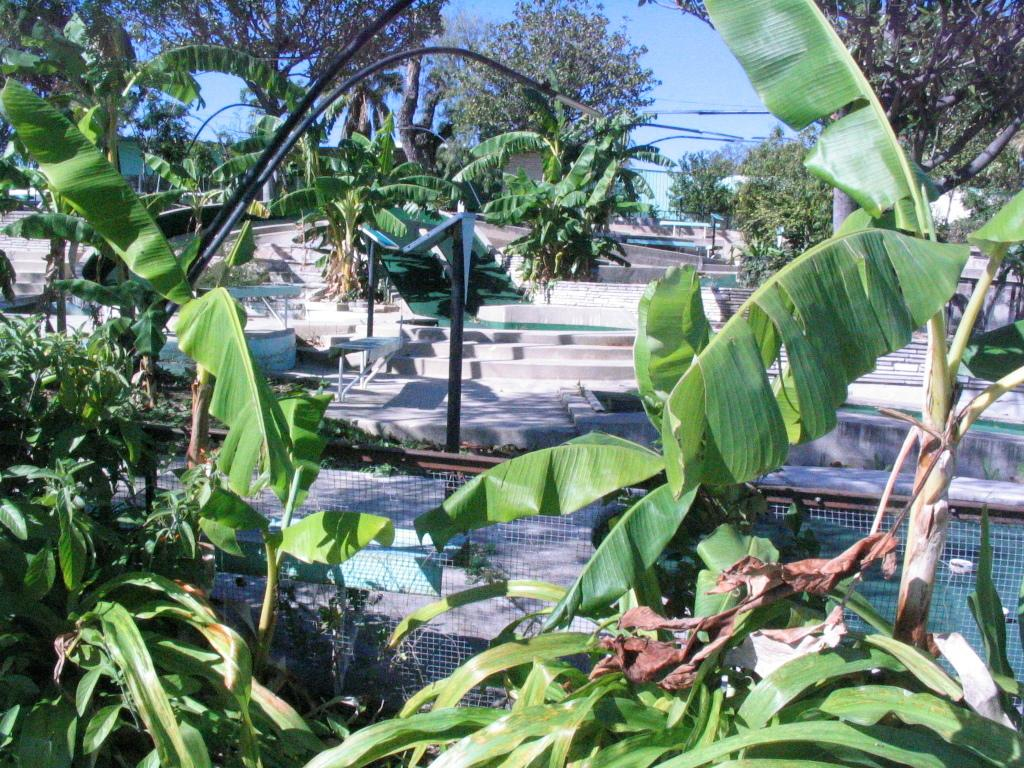What type of natural elements can be seen in the image? There are trees and plants in the image. What man-made structures are present in the image? There are poles and fencing in the image. Can you describe the unspecified things in the image? Unfortunately, the provided facts do not specify what these unspecified things are. What type of canvas is being used to paint the news in the image? There is no canvas or news present in the image; it features trees, plants, poles, and fencing. What color is the gold used to decorate the unspecified things in the image? There is no gold present in the image, and the unspecified things are not described in enough detail to determine their color or decoration. 